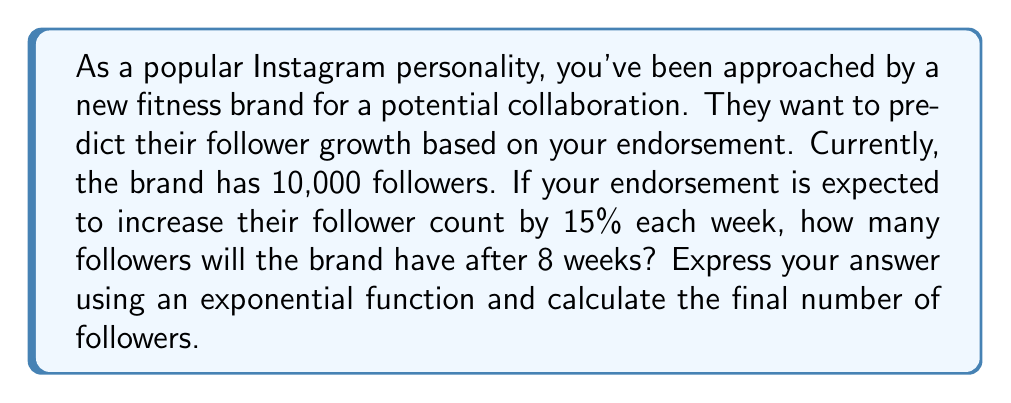Can you solve this math problem? Let's approach this step-by-step:

1) We'll use the exponential growth formula:
   $$ A = P(1 + r)^t $$
   Where:
   $A$ = final amount
   $P$ = initial amount (principal)
   $r$ = growth rate (as a decimal)
   $t$ = time period

2) Given information:
   $P = 10,000$ (initial followers)
   $r = 0.15$ (15% growth rate)
   $t = 8$ weeks

3) Plugging these values into our formula:
   $$ A = 10,000(1 + 0.15)^8 $$

4) Simplify inside the parentheses:
   $$ A = 10,000(1.15)^8 $$

5) This is our exponential function. To calculate the final number of followers, we need to evaluate this expression:

6) Using a calculator or computing software:
   $$ A = 10,000 * 3.0590 = 30,590.23 $$

7) Since we can't have a fractional number of followers, we round down to the nearest whole number.
Answer: The exponential function for follower growth is:
$$ A = 10,000(1.15)^8 $$
After 8 weeks, the brand will have approximately 30,590 followers. 